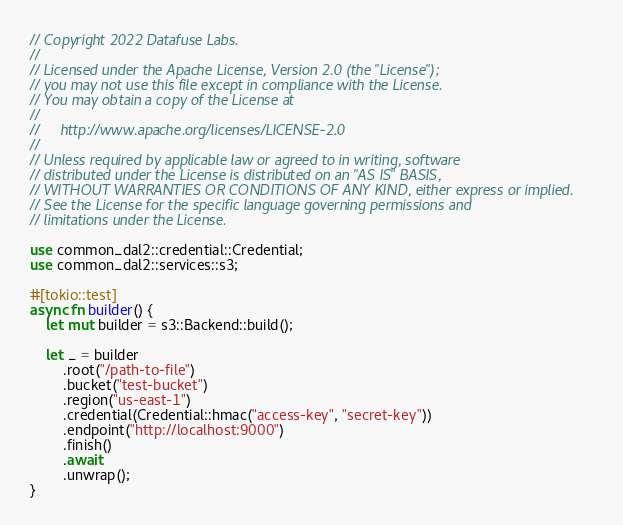Convert code to text. <code><loc_0><loc_0><loc_500><loc_500><_Rust_>// Copyright 2022 Datafuse Labs.
//
// Licensed under the Apache License, Version 2.0 (the "License");
// you may not use this file except in compliance with the License.
// You may obtain a copy of the License at
//
//     http://www.apache.org/licenses/LICENSE-2.0
//
// Unless required by applicable law or agreed to in writing, software
// distributed under the License is distributed on an "AS IS" BASIS,
// WITHOUT WARRANTIES OR CONDITIONS OF ANY KIND, either express or implied.
// See the License for the specific language governing permissions and
// limitations under the License.

use common_dal2::credential::Credential;
use common_dal2::services::s3;

#[tokio::test]
async fn builder() {
    let mut builder = s3::Backend::build();

    let _ = builder
        .root("/path-to-file")
        .bucket("test-bucket")
        .region("us-east-1")
        .credential(Credential::hmac("access-key", "secret-key"))
        .endpoint("http://localhost:9000")
        .finish()
        .await
        .unwrap();
}
</code> 